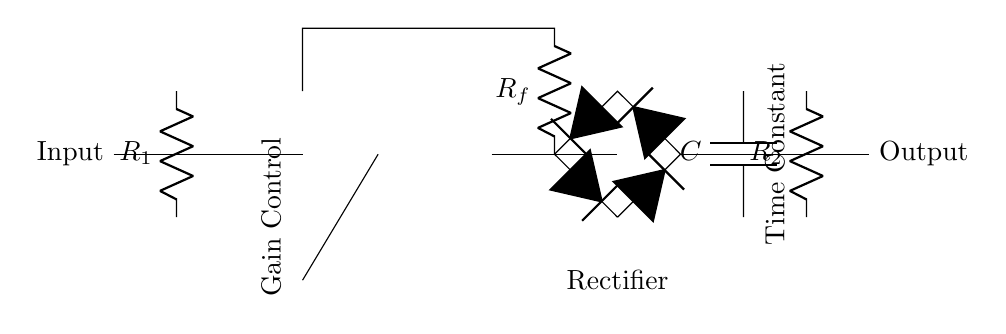What is the type of this circuit? This circuit is a compressor/limiter used for audio level management, indicated by the presence of an operational amplifier and the control elements for gain adjustment and signal rectification.
Answer: compressor/limiter What components are in the feedback loop? The feedback loop consists of a resistor labeled R_f connecting the output of the operational amplifier back to its inverting input, crucial for setting the gain of the circuit.
Answer: R_f How many diodes are present in the circuit? The circuit diagram shows a diode bridge made up of four diodes, which function together to rectify the audio signal.
Answer: four What is the purpose of the capacitor labeled C? The capacitor C is used to filter the signal, smoothing out fluctuations to produce a more consistent audio signal level, which is essential in a compressor circuit.
Answer: filter What does the gain control modify? The gain control affects the level of audio amplification applied to the input signal before it passes through the compressor/limiter, allowing for precise volume adjustments.
Answer: audio amplification What is the time constant associated with? The time constant in this diagram, shown near the capacitor and resistor labeled C and R_2, determines how quickly the circuit reacts to changes in audio signal levels, impacting the response time of the compressor.
Answer: response time What would happen if R_1 is increased? Increasing the resistance R_1 will reduce the input signal to the operational amplifier, likely resulting in a lower output level, affecting the overall gain of the circuit.
Answer: lower output level 